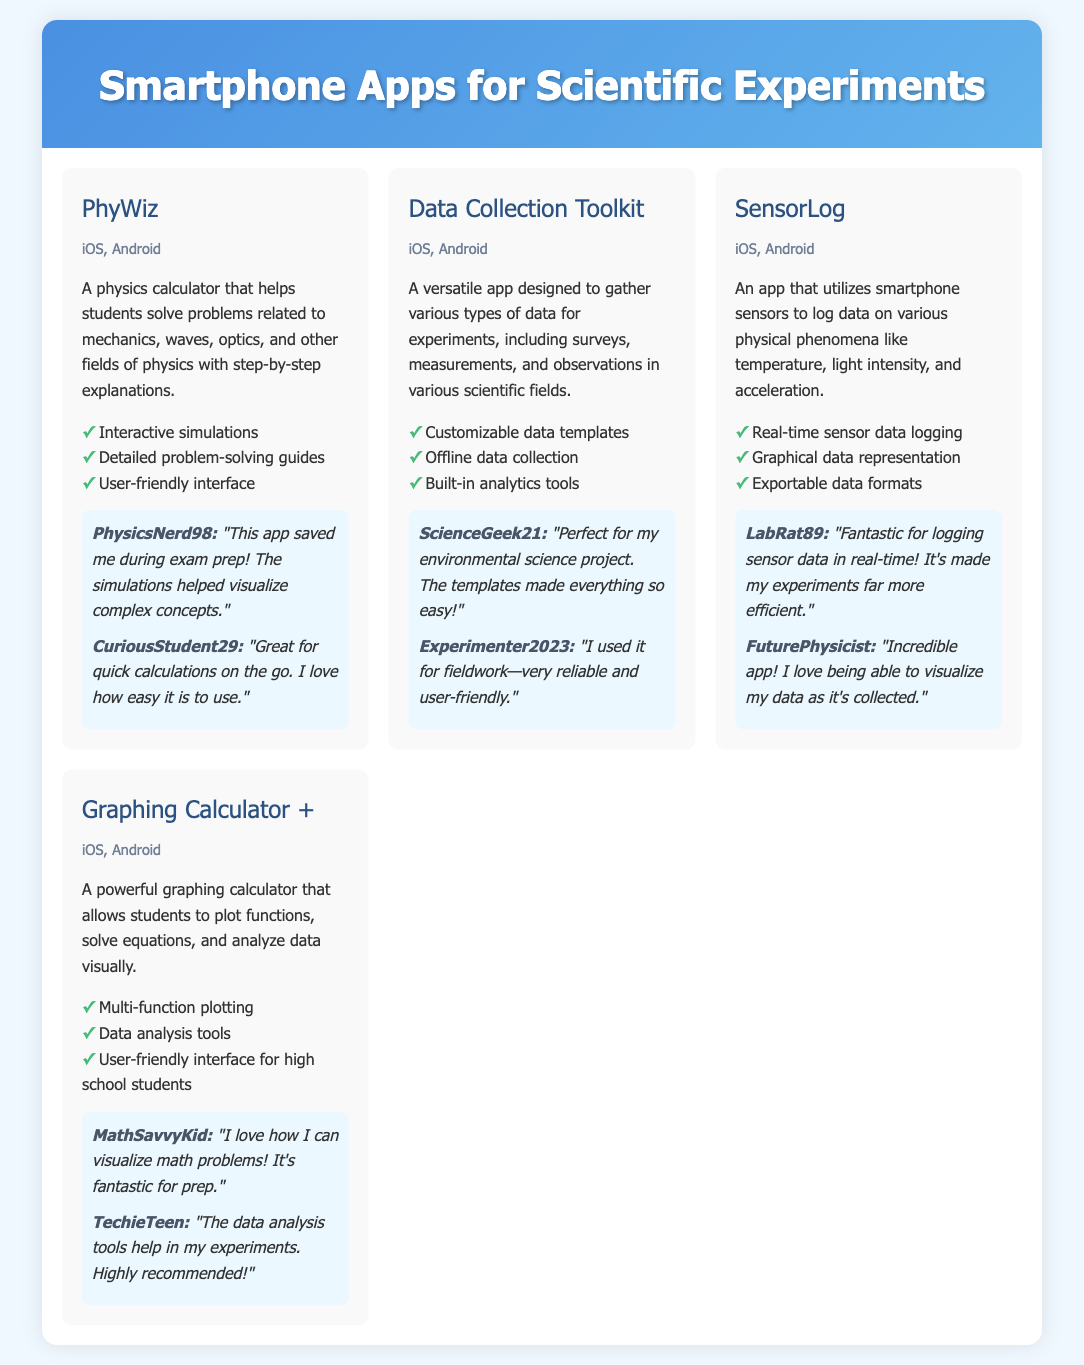What is the name of the app that helps with physics problems? The document lists "PhyWiz" as the app that helps students solve physics problems with step-by-step explanations.
Answer: PhyWiz Which platforms is the "Data Collection Toolkit" available on? The document states that the "Data Collection Toolkit" is available on iOS and Android platforms.
Answer: iOS, Android How many user reviews are featured for the app "SensorLog"? The document includes two user reviews for the "SensorLog" app.
Answer: 2 What feature does the "Graphing Calculator +" provide for high school students? The document mentions that the "Graphing Calculator +" has a user-friendly interface tailored for high school students.
Answer: User-friendly interface for high school students Which app is described as perfect for environmental science projects? The review in the document indicates that "Data Collection Toolkit" is perfect for environmental science projects due to its templates.
Answer: Data Collection Toolkit What type of data can "SensorLog" collect? "SensorLog" is designed to log data on various physical phenomena like temperature, light intensity, and acceleration.
Answer: Temperature, light intensity, acceleration Which app provides interactive simulations? According to the document, "PhyWiz" offers interactive simulations to help with physics concepts.
Answer: PhyWiz Who wrote a review stating the app "made experiments far more efficient"? The username "LabRat89" provided the review stating the app made experiments far more efficient for logging sensor data.
Answer: LabRat89 